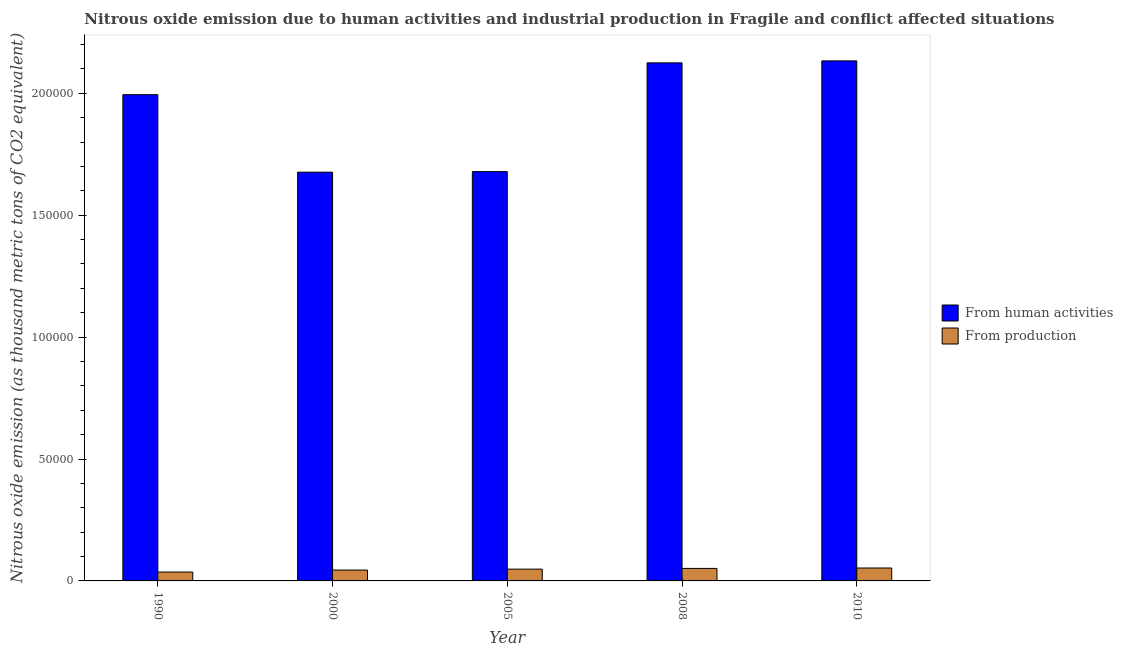How many different coloured bars are there?
Ensure brevity in your answer.  2. Are the number of bars per tick equal to the number of legend labels?
Your answer should be very brief. Yes. What is the label of the 2nd group of bars from the left?
Offer a very short reply. 2000. What is the amount of emissions from human activities in 2000?
Keep it short and to the point. 1.68e+05. Across all years, what is the maximum amount of emissions from human activities?
Your response must be concise. 2.13e+05. Across all years, what is the minimum amount of emissions from human activities?
Keep it short and to the point. 1.68e+05. What is the total amount of emissions from human activities in the graph?
Give a very brief answer. 9.61e+05. What is the difference between the amount of emissions from human activities in 1990 and that in 2000?
Keep it short and to the point. 3.18e+04. What is the difference between the amount of emissions from human activities in 2005 and the amount of emissions generated from industries in 2008?
Keep it short and to the point. -4.46e+04. What is the average amount of emissions generated from industries per year?
Provide a succinct answer. 4672.14. In the year 2005, what is the difference between the amount of emissions generated from industries and amount of emissions from human activities?
Provide a succinct answer. 0. What is the ratio of the amount of emissions from human activities in 1990 to that in 2010?
Ensure brevity in your answer.  0.94. Is the amount of emissions from human activities in 1990 less than that in 2008?
Your response must be concise. Yes. What is the difference between the highest and the second highest amount of emissions from human activities?
Your answer should be very brief. 807. What is the difference between the highest and the lowest amount of emissions generated from industries?
Your answer should be very brief. 1662.4. In how many years, is the amount of emissions generated from industries greater than the average amount of emissions generated from industries taken over all years?
Your answer should be compact. 3. What does the 1st bar from the left in 2010 represents?
Your response must be concise. From human activities. What does the 2nd bar from the right in 1990 represents?
Your answer should be compact. From human activities. How many years are there in the graph?
Keep it short and to the point. 5. Does the graph contain any zero values?
Ensure brevity in your answer.  No. How many legend labels are there?
Give a very brief answer. 2. How are the legend labels stacked?
Your answer should be very brief. Vertical. What is the title of the graph?
Give a very brief answer. Nitrous oxide emission due to human activities and industrial production in Fragile and conflict affected situations. What is the label or title of the Y-axis?
Offer a very short reply. Nitrous oxide emission (as thousand metric tons of CO2 equivalent). What is the Nitrous oxide emission (as thousand metric tons of CO2 equivalent) in From human activities in 1990?
Provide a succinct answer. 1.99e+05. What is the Nitrous oxide emission (as thousand metric tons of CO2 equivalent) in From production in 1990?
Your answer should be compact. 3634.4. What is the Nitrous oxide emission (as thousand metric tons of CO2 equivalent) of From human activities in 2000?
Offer a terse response. 1.68e+05. What is the Nitrous oxide emission (as thousand metric tons of CO2 equivalent) in From production in 2000?
Provide a succinct answer. 4463.5. What is the Nitrous oxide emission (as thousand metric tons of CO2 equivalent) in From human activities in 2005?
Your answer should be very brief. 1.68e+05. What is the Nitrous oxide emission (as thousand metric tons of CO2 equivalent) in From production in 2005?
Provide a short and direct response. 4837.1. What is the Nitrous oxide emission (as thousand metric tons of CO2 equivalent) in From human activities in 2008?
Your answer should be very brief. 2.12e+05. What is the Nitrous oxide emission (as thousand metric tons of CO2 equivalent) of From production in 2008?
Offer a very short reply. 5128.9. What is the Nitrous oxide emission (as thousand metric tons of CO2 equivalent) of From human activities in 2010?
Provide a short and direct response. 2.13e+05. What is the Nitrous oxide emission (as thousand metric tons of CO2 equivalent) in From production in 2010?
Your response must be concise. 5296.8. Across all years, what is the maximum Nitrous oxide emission (as thousand metric tons of CO2 equivalent) of From human activities?
Keep it short and to the point. 2.13e+05. Across all years, what is the maximum Nitrous oxide emission (as thousand metric tons of CO2 equivalent) of From production?
Keep it short and to the point. 5296.8. Across all years, what is the minimum Nitrous oxide emission (as thousand metric tons of CO2 equivalent) in From human activities?
Your answer should be very brief. 1.68e+05. Across all years, what is the minimum Nitrous oxide emission (as thousand metric tons of CO2 equivalent) in From production?
Offer a terse response. 3634.4. What is the total Nitrous oxide emission (as thousand metric tons of CO2 equivalent) in From human activities in the graph?
Your answer should be compact. 9.61e+05. What is the total Nitrous oxide emission (as thousand metric tons of CO2 equivalent) in From production in the graph?
Keep it short and to the point. 2.34e+04. What is the difference between the Nitrous oxide emission (as thousand metric tons of CO2 equivalent) in From human activities in 1990 and that in 2000?
Your answer should be compact. 3.18e+04. What is the difference between the Nitrous oxide emission (as thousand metric tons of CO2 equivalent) in From production in 1990 and that in 2000?
Offer a very short reply. -829.1. What is the difference between the Nitrous oxide emission (as thousand metric tons of CO2 equivalent) in From human activities in 1990 and that in 2005?
Keep it short and to the point. 3.16e+04. What is the difference between the Nitrous oxide emission (as thousand metric tons of CO2 equivalent) in From production in 1990 and that in 2005?
Ensure brevity in your answer.  -1202.7. What is the difference between the Nitrous oxide emission (as thousand metric tons of CO2 equivalent) of From human activities in 1990 and that in 2008?
Your response must be concise. -1.30e+04. What is the difference between the Nitrous oxide emission (as thousand metric tons of CO2 equivalent) of From production in 1990 and that in 2008?
Ensure brevity in your answer.  -1494.5. What is the difference between the Nitrous oxide emission (as thousand metric tons of CO2 equivalent) of From human activities in 1990 and that in 2010?
Offer a very short reply. -1.38e+04. What is the difference between the Nitrous oxide emission (as thousand metric tons of CO2 equivalent) in From production in 1990 and that in 2010?
Make the answer very short. -1662.4. What is the difference between the Nitrous oxide emission (as thousand metric tons of CO2 equivalent) of From human activities in 2000 and that in 2005?
Provide a short and direct response. -238.1. What is the difference between the Nitrous oxide emission (as thousand metric tons of CO2 equivalent) of From production in 2000 and that in 2005?
Your answer should be very brief. -373.6. What is the difference between the Nitrous oxide emission (as thousand metric tons of CO2 equivalent) of From human activities in 2000 and that in 2008?
Offer a very short reply. -4.48e+04. What is the difference between the Nitrous oxide emission (as thousand metric tons of CO2 equivalent) of From production in 2000 and that in 2008?
Provide a short and direct response. -665.4. What is the difference between the Nitrous oxide emission (as thousand metric tons of CO2 equivalent) in From human activities in 2000 and that in 2010?
Your answer should be compact. -4.57e+04. What is the difference between the Nitrous oxide emission (as thousand metric tons of CO2 equivalent) in From production in 2000 and that in 2010?
Offer a terse response. -833.3. What is the difference between the Nitrous oxide emission (as thousand metric tons of CO2 equivalent) in From human activities in 2005 and that in 2008?
Offer a very short reply. -4.46e+04. What is the difference between the Nitrous oxide emission (as thousand metric tons of CO2 equivalent) of From production in 2005 and that in 2008?
Provide a succinct answer. -291.8. What is the difference between the Nitrous oxide emission (as thousand metric tons of CO2 equivalent) in From human activities in 2005 and that in 2010?
Ensure brevity in your answer.  -4.54e+04. What is the difference between the Nitrous oxide emission (as thousand metric tons of CO2 equivalent) in From production in 2005 and that in 2010?
Make the answer very short. -459.7. What is the difference between the Nitrous oxide emission (as thousand metric tons of CO2 equivalent) in From human activities in 2008 and that in 2010?
Give a very brief answer. -807. What is the difference between the Nitrous oxide emission (as thousand metric tons of CO2 equivalent) of From production in 2008 and that in 2010?
Provide a short and direct response. -167.9. What is the difference between the Nitrous oxide emission (as thousand metric tons of CO2 equivalent) in From human activities in 1990 and the Nitrous oxide emission (as thousand metric tons of CO2 equivalent) in From production in 2000?
Provide a short and direct response. 1.95e+05. What is the difference between the Nitrous oxide emission (as thousand metric tons of CO2 equivalent) in From human activities in 1990 and the Nitrous oxide emission (as thousand metric tons of CO2 equivalent) in From production in 2005?
Offer a terse response. 1.95e+05. What is the difference between the Nitrous oxide emission (as thousand metric tons of CO2 equivalent) in From human activities in 1990 and the Nitrous oxide emission (as thousand metric tons of CO2 equivalent) in From production in 2008?
Make the answer very short. 1.94e+05. What is the difference between the Nitrous oxide emission (as thousand metric tons of CO2 equivalent) in From human activities in 1990 and the Nitrous oxide emission (as thousand metric tons of CO2 equivalent) in From production in 2010?
Offer a terse response. 1.94e+05. What is the difference between the Nitrous oxide emission (as thousand metric tons of CO2 equivalent) in From human activities in 2000 and the Nitrous oxide emission (as thousand metric tons of CO2 equivalent) in From production in 2005?
Your response must be concise. 1.63e+05. What is the difference between the Nitrous oxide emission (as thousand metric tons of CO2 equivalent) of From human activities in 2000 and the Nitrous oxide emission (as thousand metric tons of CO2 equivalent) of From production in 2008?
Your answer should be very brief. 1.63e+05. What is the difference between the Nitrous oxide emission (as thousand metric tons of CO2 equivalent) of From human activities in 2000 and the Nitrous oxide emission (as thousand metric tons of CO2 equivalent) of From production in 2010?
Give a very brief answer. 1.62e+05. What is the difference between the Nitrous oxide emission (as thousand metric tons of CO2 equivalent) in From human activities in 2005 and the Nitrous oxide emission (as thousand metric tons of CO2 equivalent) in From production in 2008?
Keep it short and to the point. 1.63e+05. What is the difference between the Nitrous oxide emission (as thousand metric tons of CO2 equivalent) of From human activities in 2005 and the Nitrous oxide emission (as thousand metric tons of CO2 equivalent) of From production in 2010?
Make the answer very short. 1.63e+05. What is the difference between the Nitrous oxide emission (as thousand metric tons of CO2 equivalent) in From human activities in 2008 and the Nitrous oxide emission (as thousand metric tons of CO2 equivalent) in From production in 2010?
Make the answer very short. 2.07e+05. What is the average Nitrous oxide emission (as thousand metric tons of CO2 equivalent) in From human activities per year?
Provide a succinct answer. 1.92e+05. What is the average Nitrous oxide emission (as thousand metric tons of CO2 equivalent) in From production per year?
Make the answer very short. 4672.14. In the year 1990, what is the difference between the Nitrous oxide emission (as thousand metric tons of CO2 equivalent) in From human activities and Nitrous oxide emission (as thousand metric tons of CO2 equivalent) in From production?
Make the answer very short. 1.96e+05. In the year 2000, what is the difference between the Nitrous oxide emission (as thousand metric tons of CO2 equivalent) of From human activities and Nitrous oxide emission (as thousand metric tons of CO2 equivalent) of From production?
Make the answer very short. 1.63e+05. In the year 2005, what is the difference between the Nitrous oxide emission (as thousand metric tons of CO2 equivalent) in From human activities and Nitrous oxide emission (as thousand metric tons of CO2 equivalent) in From production?
Offer a terse response. 1.63e+05. In the year 2008, what is the difference between the Nitrous oxide emission (as thousand metric tons of CO2 equivalent) of From human activities and Nitrous oxide emission (as thousand metric tons of CO2 equivalent) of From production?
Provide a short and direct response. 2.07e+05. In the year 2010, what is the difference between the Nitrous oxide emission (as thousand metric tons of CO2 equivalent) of From human activities and Nitrous oxide emission (as thousand metric tons of CO2 equivalent) of From production?
Ensure brevity in your answer.  2.08e+05. What is the ratio of the Nitrous oxide emission (as thousand metric tons of CO2 equivalent) in From human activities in 1990 to that in 2000?
Your answer should be compact. 1.19. What is the ratio of the Nitrous oxide emission (as thousand metric tons of CO2 equivalent) of From production in 1990 to that in 2000?
Provide a succinct answer. 0.81. What is the ratio of the Nitrous oxide emission (as thousand metric tons of CO2 equivalent) of From human activities in 1990 to that in 2005?
Keep it short and to the point. 1.19. What is the ratio of the Nitrous oxide emission (as thousand metric tons of CO2 equivalent) in From production in 1990 to that in 2005?
Offer a very short reply. 0.75. What is the ratio of the Nitrous oxide emission (as thousand metric tons of CO2 equivalent) of From human activities in 1990 to that in 2008?
Your response must be concise. 0.94. What is the ratio of the Nitrous oxide emission (as thousand metric tons of CO2 equivalent) in From production in 1990 to that in 2008?
Offer a terse response. 0.71. What is the ratio of the Nitrous oxide emission (as thousand metric tons of CO2 equivalent) of From human activities in 1990 to that in 2010?
Offer a very short reply. 0.94. What is the ratio of the Nitrous oxide emission (as thousand metric tons of CO2 equivalent) of From production in 1990 to that in 2010?
Offer a terse response. 0.69. What is the ratio of the Nitrous oxide emission (as thousand metric tons of CO2 equivalent) of From production in 2000 to that in 2005?
Provide a short and direct response. 0.92. What is the ratio of the Nitrous oxide emission (as thousand metric tons of CO2 equivalent) in From human activities in 2000 to that in 2008?
Keep it short and to the point. 0.79. What is the ratio of the Nitrous oxide emission (as thousand metric tons of CO2 equivalent) in From production in 2000 to that in 2008?
Provide a succinct answer. 0.87. What is the ratio of the Nitrous oxide emission (as thousand metric tons of CO2 equivalent) in From human activities in 2000 to that in 2010?
Provide a succinct answer. 0.79. What is the ratio of the Nitrous oxide emission (as thousand metric tons of CO2 equivalent) of From production in 2000 to that in 2010?
Provide a succinct answer. 0.84. What is the ratio of the Nitrous oxide emission (as thousand metric tons of CO2 equivalent) in From human activities in 2005 to that in 2008?
Keep it short and to the point. 0.79. What is the ratio of the Nitrous oxide emission (as thousand metric tons of CO2 equivalent) of From production in 2005 to that in 2008?
Your response must be concise. 0.94. What is the ratio of the Nitrous oxide emission (as thousand metric tons of CO2 equivalent) in From human activities in 2005 to that in 2010?
Give a very brief answer. 0.79. What is the ratio of the Nitrous oxide emission (as thousand metric tons of CO2 equivalent) of From production in 2005 to that in 2010?
Keep it short and to the point. 0.91. What is the ratio of the Nitrous oxide emission (as thousand metric tons of CO2 equivalent) in From production in 2008 to that in 2010?
Make the answer very short. 0.97. What is the difference between the highest and the second highest Nitrous oxide emission (as thousand metric tons of CO2 equivalent) in From human activities?
Offer a terse response. 807. What is the difference between the highest and the second highest Nitrous oxide emission (as thousand metric tons of CO2 equivalent) in From production?
Offer a terse response. 167.9. What is the difference between the highest and the lowest Nitrous oxide emission (as thousand metric tons of CO2 equivalent) of From human activities?
Keep it short and to the point. 4.57e+04. What is the difference between the highest and the lowest Nitrous oxide emission (as thousand metric tons of CO2 equivalent) of From production?
Keep it short and to the point. 1662.4. 